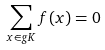<formula> <loc_0><loc_0><loc_500><loc_500>\sum _ { x \in g K } f ( x ) = 0</formula> 